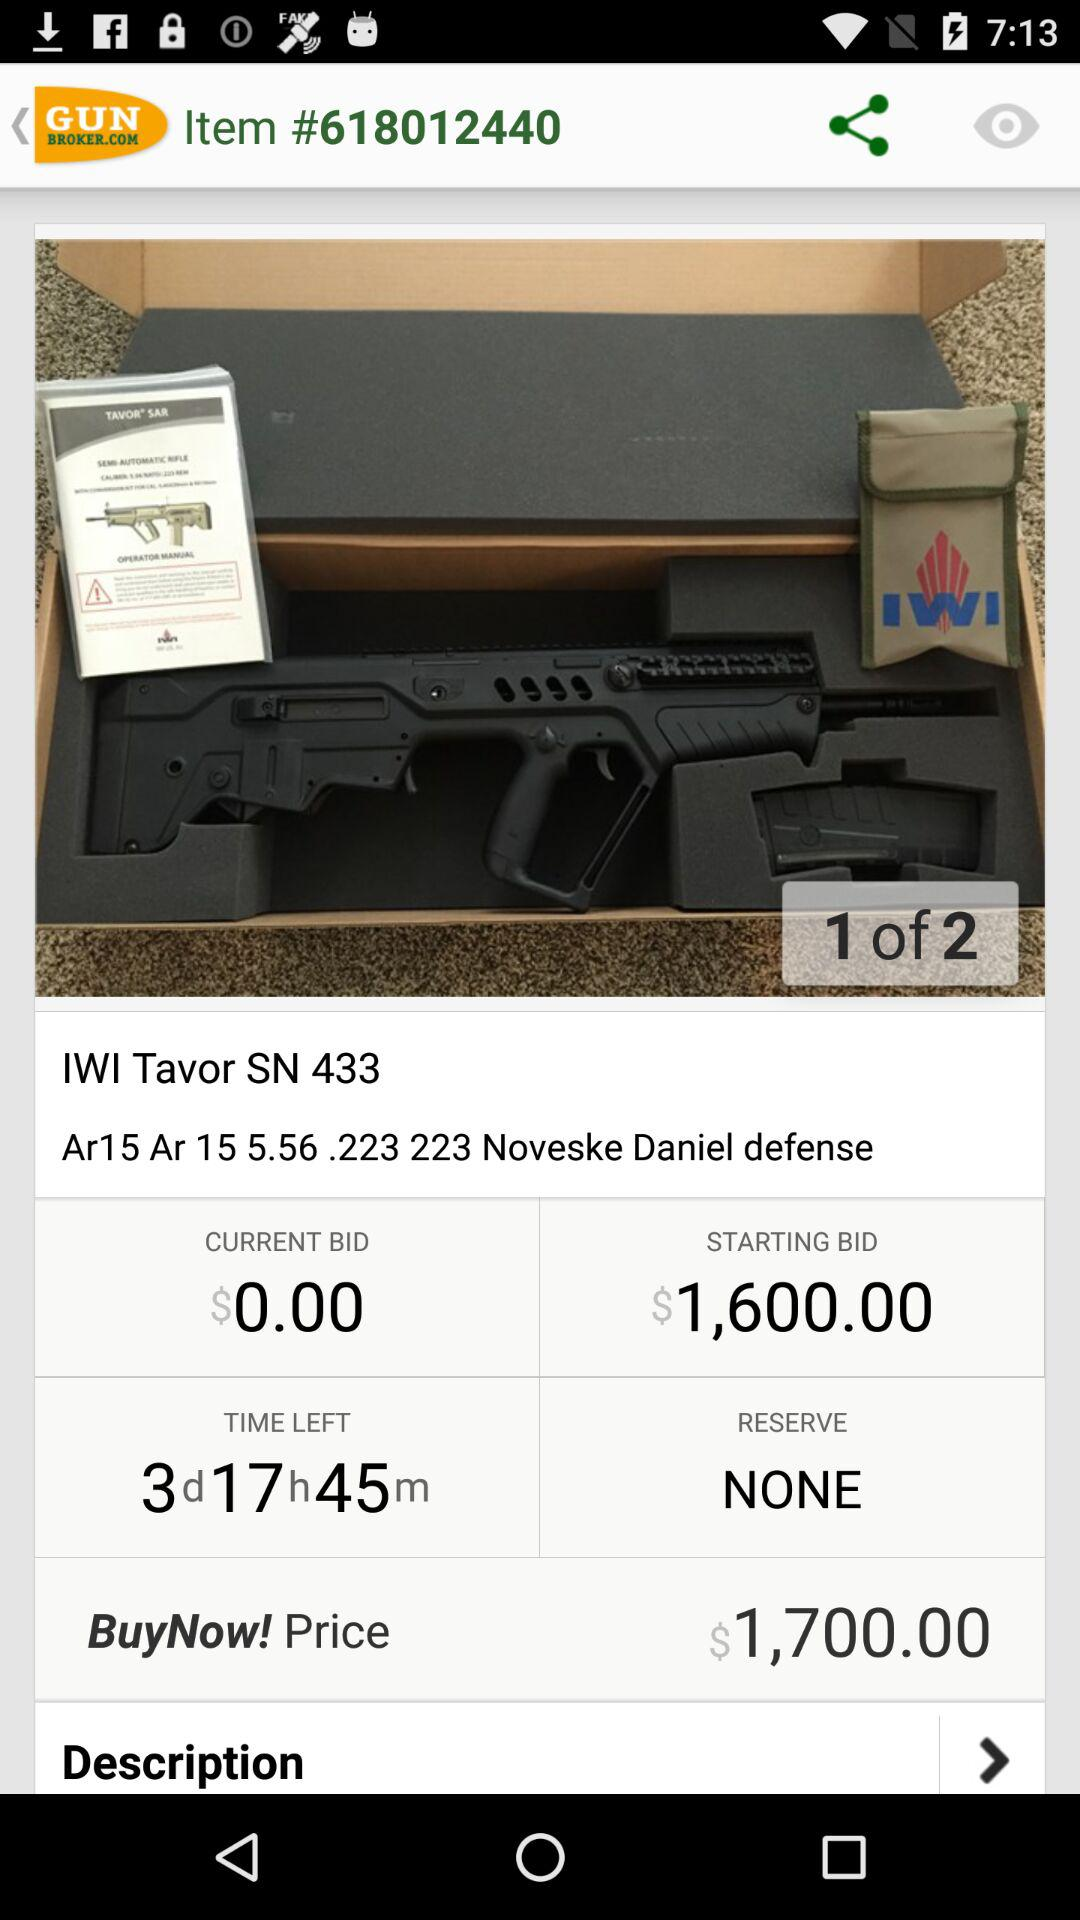How much time is left? The time left is 3 days, 17 hours and 45 minutes. 